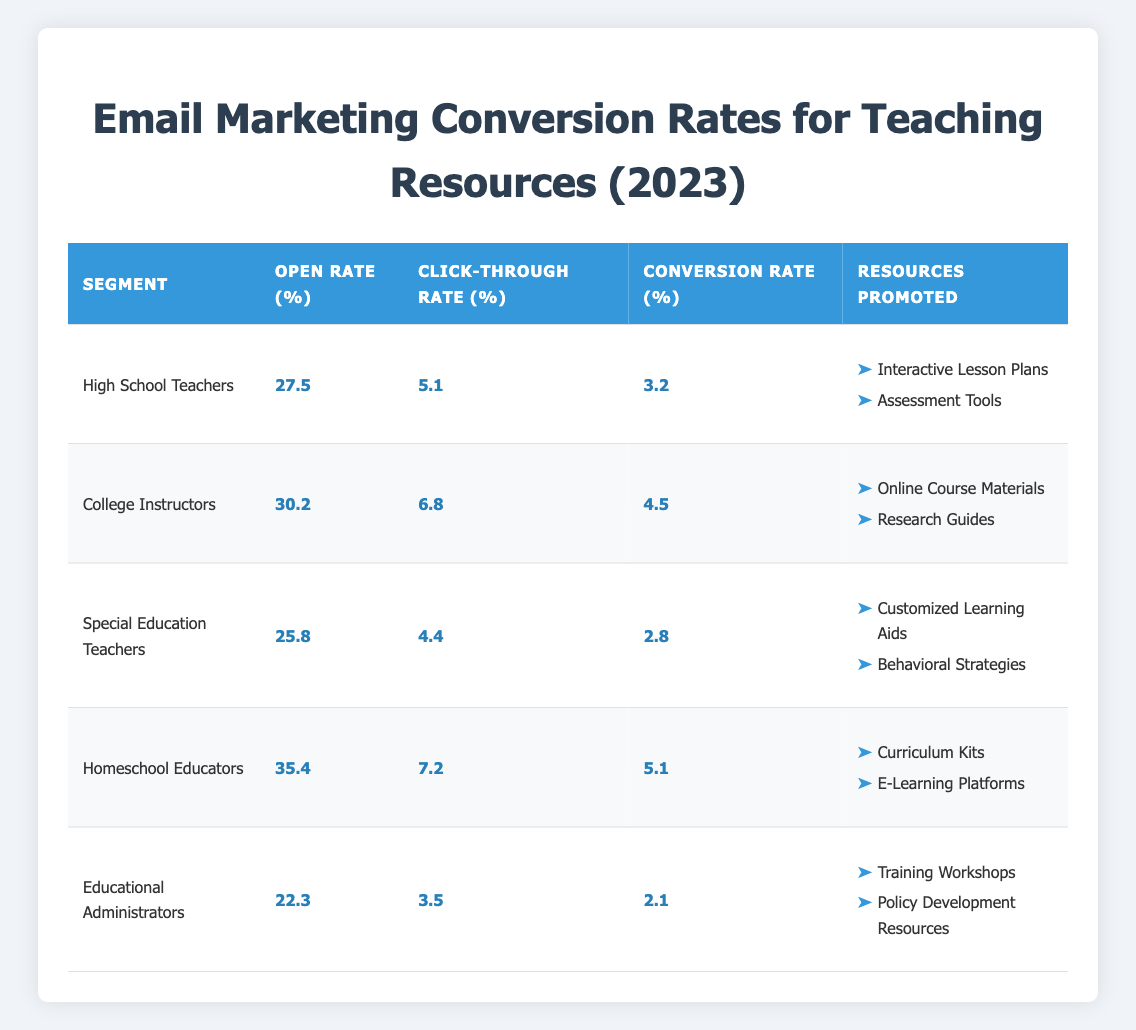What is the open rate for College Instructors? The table directly shows the open rate for each segment. For College Instructors, it lists an open rate of 30.2%.
Answer: 30.2% Which segment has the highest conversion rate? By comparing the conversion rates across all segments shown in the table, Homeschool Educators have the highest conversion rate of 5.1%.
Answer: Homeschool Educators What is the average click-through rate across all segments? To calculate the average click-through rate, sum the individual rates: (5.1 + 6.8 + 4.4 + 7.2 + 3.5) = 27.0%. There are five segments, so the average is 27.0% / 5 = 5.4%.
Answer: 5.4% Is the open rate for Special Education Teachers higher than that of Educational Administrators? The data shows that the open rate for Special Education Teachers is 25.8%, and for Educational Administrators, it is 22.3%. Since 25.8% > 22.3%, the statement is true.
Answer: Yes How much greater is the conversion rate of Homeschool Educators compared to High School Teachers? The conversion rate for Homeschool Educators is 5.1% and for High School Teachers is 3.2%. The difference is calculated as 5.1% - 3.2% = 1.9%.
Answer: 1.9% 